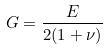Convert formula to latex. <formula><loc_0><loc_0><loc_500><loc_500>G = \frac { E } { 2 ( 1 + \nu ) }</formula> 